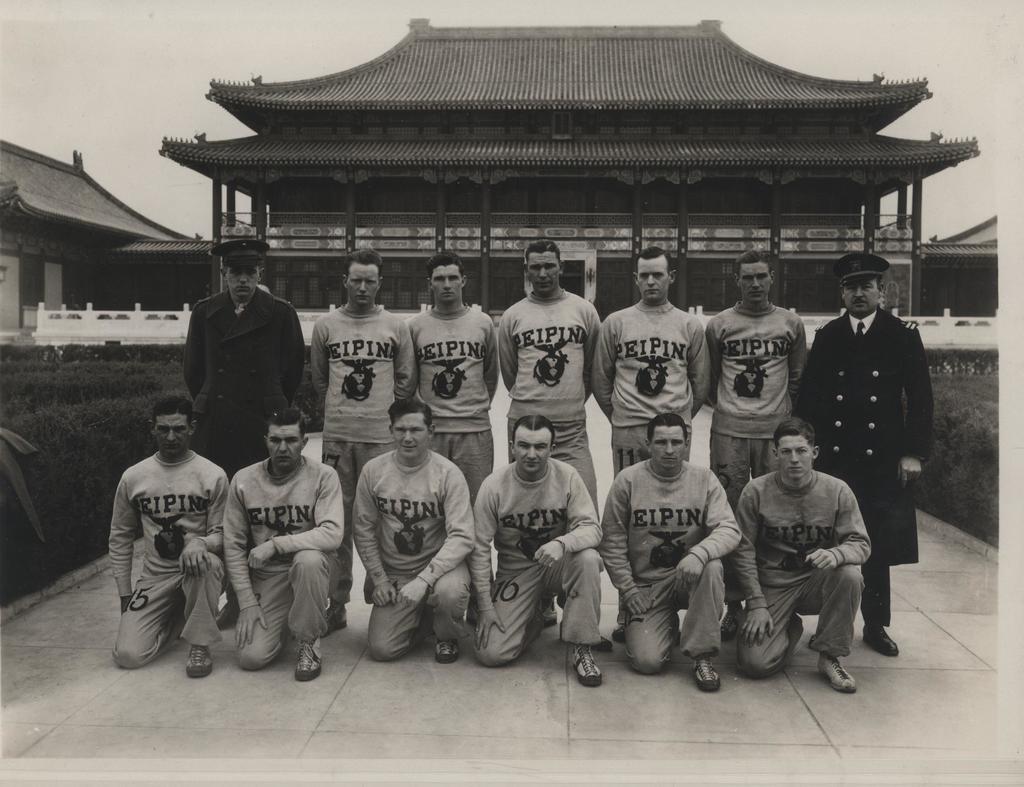What is their team name?
Keep it short and to the point. Eipin. 